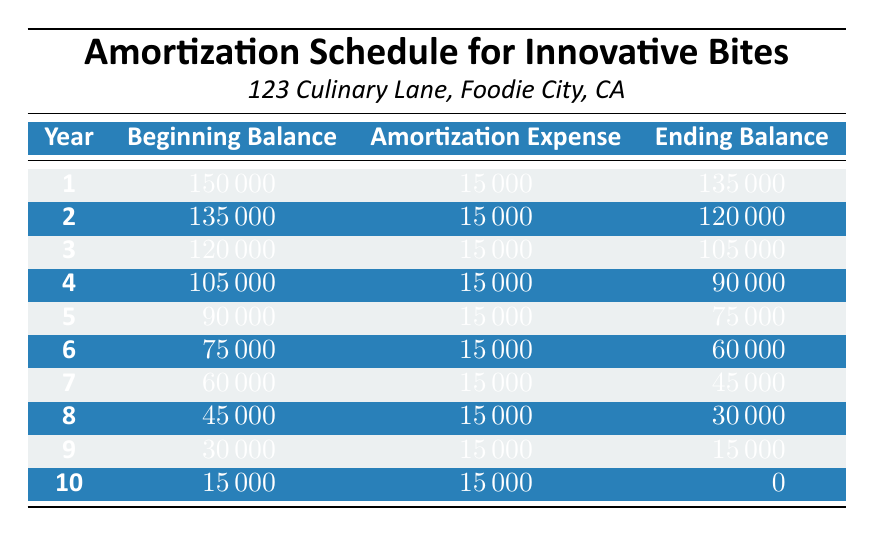What is the total cost of leasehold improvements for Innovative Bites? The total cost is given directly in the data as 150,000.
Answer: 150000 What was the beginning balance at the end of year 5? At the end of year 5, the ending balance is 75,000, which means the beginning balance for year 6 will be 75,000.
Answer: 75000 How much was the amortization expense in year 4? The amortization expense for each year is consistent and listed as 15,000, specifically for year 4.
Answer: 15000 What is the ending balance after year 7? The ending balance for year 7 is provided directly in the table, which shows that it is 45,000.
Answer: 45000 Is the annual amortization the same for every year? Yes, the annual amortization expense is consistently 15,000 for all ten years, as presented in the table.
Answer: Yes What is the average ending balance over the 10 years? The ending balances for ten years are: 135,000; 120,000; 105,000; 90,000; 75,000; 60,000; 45,000; 30,000; 15,000; and 0. Summing these gives 750,000, and dividing by 10 yields an average of 75,000.
Answer: 75000 What was the cumulative amortization expense by the end of year 9? The cumulative amortization expense can be calculated by taking the annual amortization (15,000) multiplied by the number of years (9), which equals 135,000.
Answer: 135000 What is the beginning balance for year 2? The beginning balance for year 2 is found in the table, showing it as 135,000, which is the ending balance of year 1.
Answer: 135000 Did the beginning balance decrease each year? Yes, the beginning balance decreases each year as amortization expenses are deducted, as shown by the values in the table.
Answer: Yes 